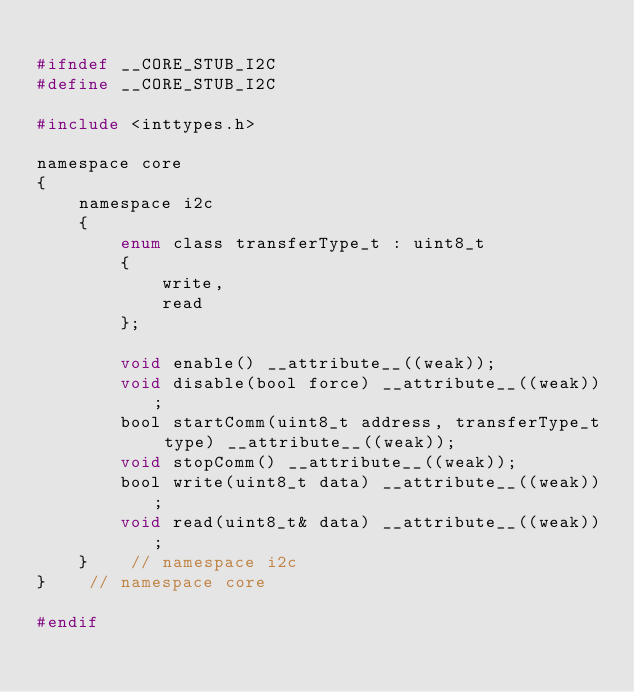<code> <loc_0><loc_0><loc_500><loc_500><_C_>
#ifndef __CORE_STUB_I2C
#define __CORE_STUB_I2C

#include <inttypes.h>

namespace core
{
    namespace i2c
    {
        enum class transferType_t : uint8_t
        {
            write,
            read
        };

        void enable() __attribute__((weak));
        void disable(bool force) __attribute__((weak));
        bool startComm(uint8_t address, transferType_t type) __attribute__((weak));
        void stopComm() __attribute__((weak));
        bool write(uint8_t data) __attribute__((weak));
        void read(uint8_t& data) __attribute__((weak));
    }    // namespace i2c
}    // namespace core

#endif</code> 